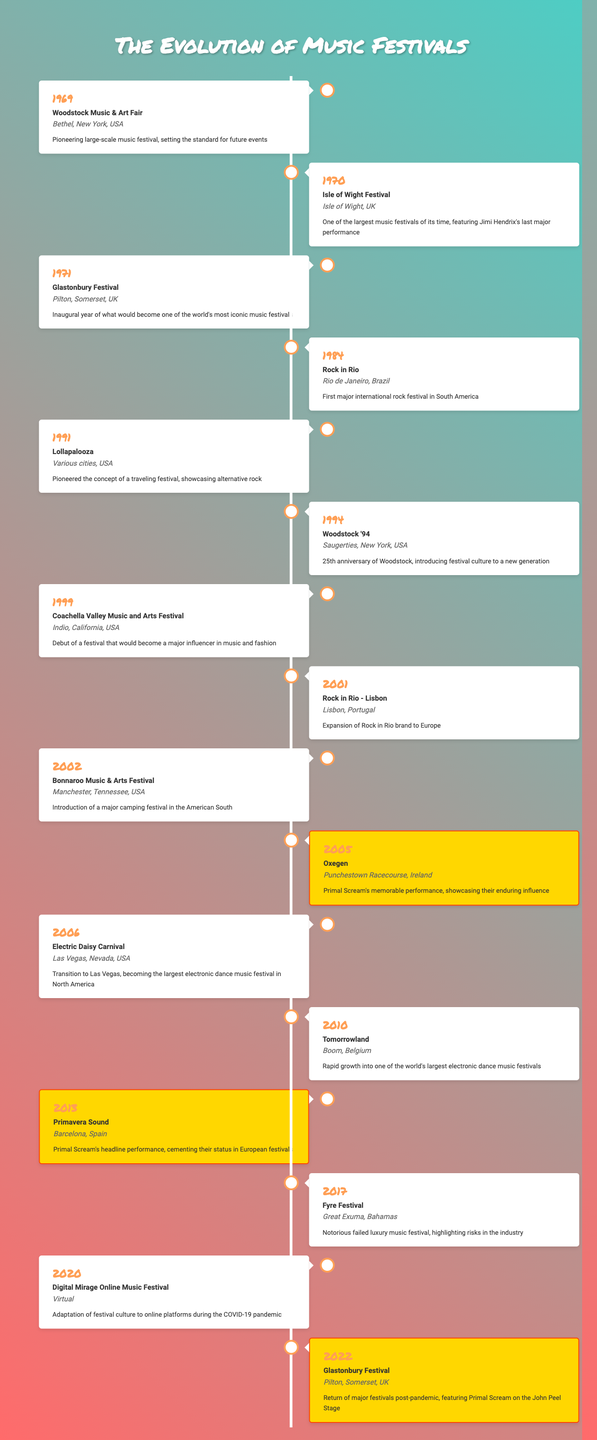What year did the Woodstock Music & Art Fair take place? The table lists the event "Woodstock Music & Art Fair" under the year 1969, making it clear that this was the year it occurred.
Answer: 1969 Which festival featured Jimi Hendrix's last major performance? The table indicates that the "Isle of Wight Festival" in 1970 is significant for featuring Jimi Hendrix's last major performance.
Answer: Isle of Wight Festival How many festivals listed occurred in the 2000s? The events in the table for the 2000s are for the years 2001 (Rock in Rio - Lisbon), 2002 (Bonnaroo Music & Arts Festival), 2005 (Oxegen), 2006 (Electric Daisy Carnival), and 2010 (Tomorrowland), giving a total of five festivals.
Answer: 5 What is the significance of the Fyre Festival? According to the table, the significance of the "Fyre Festival" in 2017 is that it was a notorious failed luxury music festival which highlighted risks in the music festival industry.
Answer: Notorious failed luxury music festival highlighting risks in the industry In which two years did Primal Scream perform at festivals mentioned in the table? The table lists "Oxegen" in 2005 and "Primavera Sound" in 2013 as events where Primal Scream performed, making those the two years they are noted for performing.
Answer: 2005, 2013 Was the "Digital Mirage Online Music Festival" held in a physical location? The table states that the "Digital Mirage Online Music Festival" in 2020 took place in a virtual setting, indicating it was not held in a physical location.
Answer: No How does the significance of the first Glastonbury Festival compare to its return in 2022? The first Glastonbury Festival in 1971 marked its inaugural year and became iconic, while the 2022 event was significant for marking the return of major festivals post-pandemic. This shows a shift from the festival's establishment to its resilience and renewal after challenges.
Answer: Shift from establishment to post-pandemic return What were the locations for the first festival in the table and the latest festival mentioned? The first festival noted is the "Woodstock Music & Art Fair," held in Bethel, New York in 1969, while the latest is the "Glastonbury Festival" in Pilton, Somerset, UK in 2022, indicating the geographical diversity of festivals over time.
Answer: Bethel, New York; Pilton, Somerset, UK Which festival is noted for introducing festival culture to a new generation? The table specifies "Woodstock '94" in 1994 as the festival that introduced festival culture to a new generation, signifying its cultural relevance at the time.
Answer: Woodstock '94 